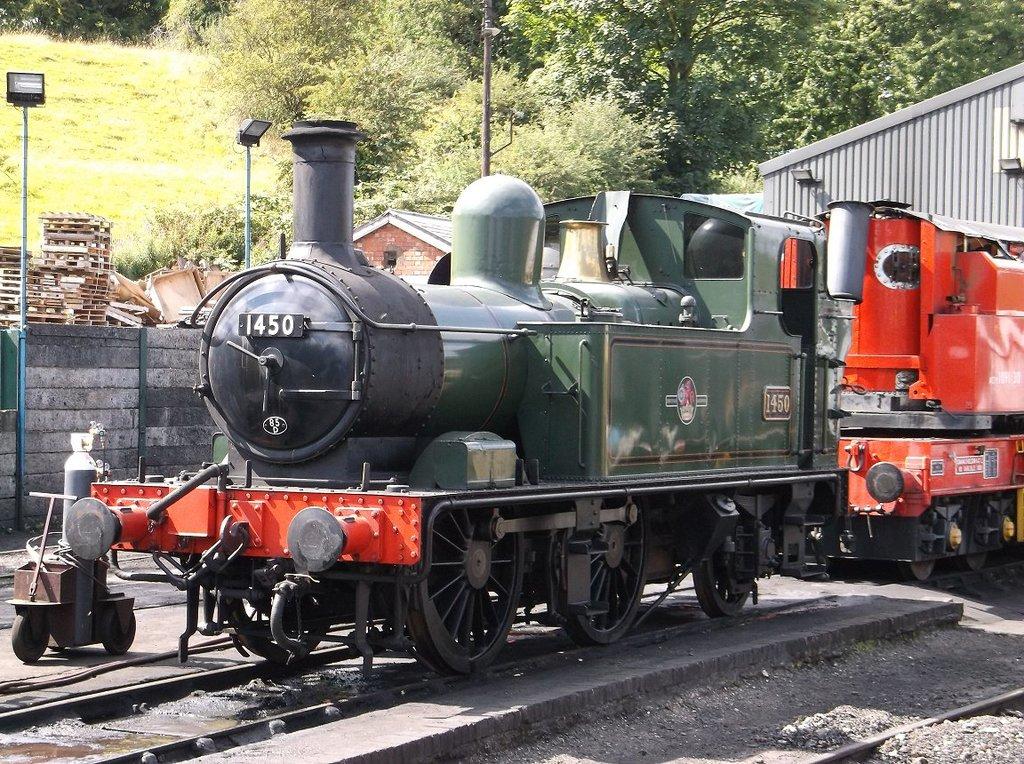The train number is?
Offer a very short reply. 1450. 